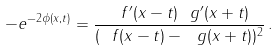<formula> <loc_0><loc_0><loc_500><loc_500>- e ^ { - 2 \phi ( x , t ) } = \frac { \ f ^ { \prime } ( x - t ) \ g ^ { \prime } ( x + t ) } { ( \ f ( x - t ) - \ g ( x + t ) ) ^ { 2 } } \, .</formula> 